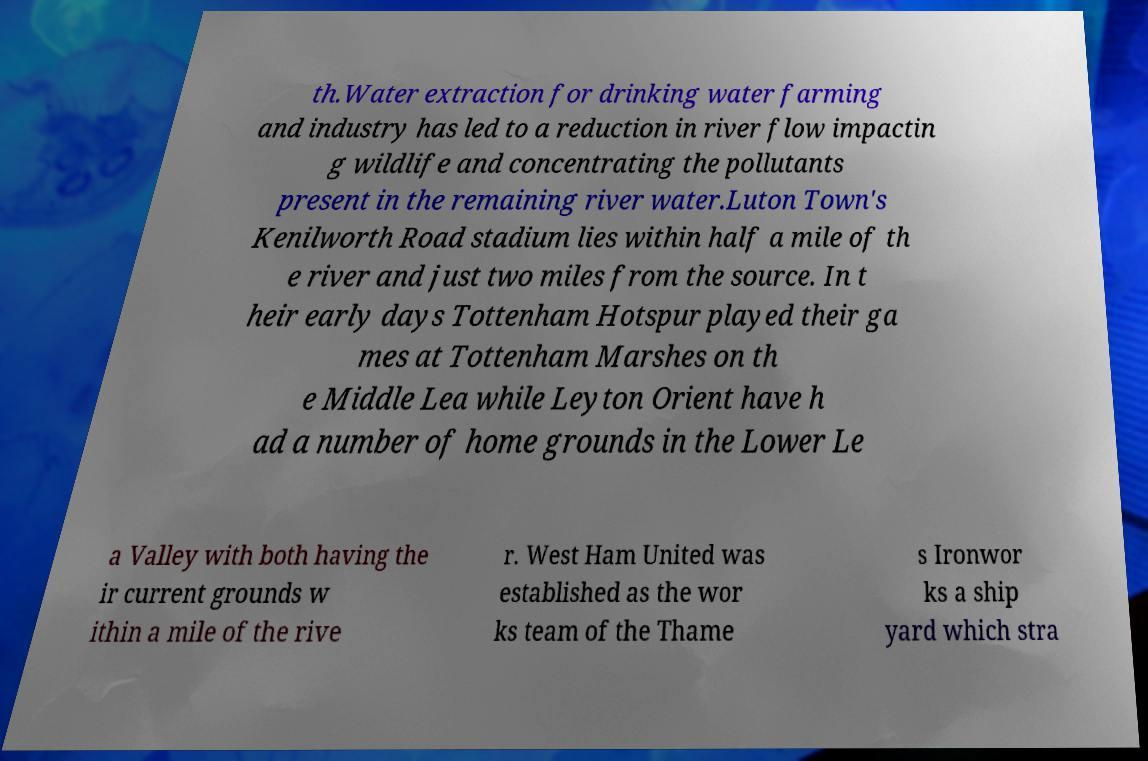Could you assist in decoding the text presented in this image and type it out clearly? th.Water extraction for drinking water farming and industry has led to a reduction in river flow impactin g wildlife and concentrating the pollutants present in the remaining river water.Luton Town's Kenilworth Road stadium lies within half a mile of th e river and just two miles from the source. In t heir early days Tottenham Hotspur played their ga mes at Tottenham Marshes on th e Middle Lea while Leyton Orient have h ad a number of home grounds in the Lower Le a Valley with both having the ir current grounds w ithin a mile of the rive r. West Ham United was established as the wor ks team of the Thame s Ironwor ks a ship yard which stra 